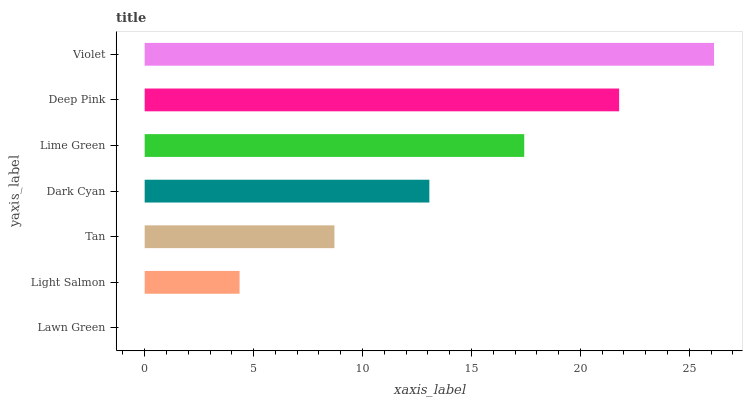Is Lawn Green the minimum?
Answer yes or no. Yes. Is Violet the maximum?
Answer yes or no. Yes. Is Light Salmon the minimum?
Answer yes or no. No. Is Light Salmon the maximum?
Answer yes or no. No. Is Light Salmon greater than Lawn Green?
Answer yes or no. Yes. Is Lawn Green less than Light Salmon?
Answer yes or no. Yes. Is Lawn Green greater than Light Salmon?
Answer yes or no. No. Is Light Salmon less than Lawn Green?
Answer yes or no. No. Is Dark Cyan the high median?
Answer yes or no. Yes. Is Dark Cyan the low median?
Answer yes or no. Yes. Is Light Salmon the high median?
Answer yes or no. No. Is Tan the low median?
Answer yes or no. No. 